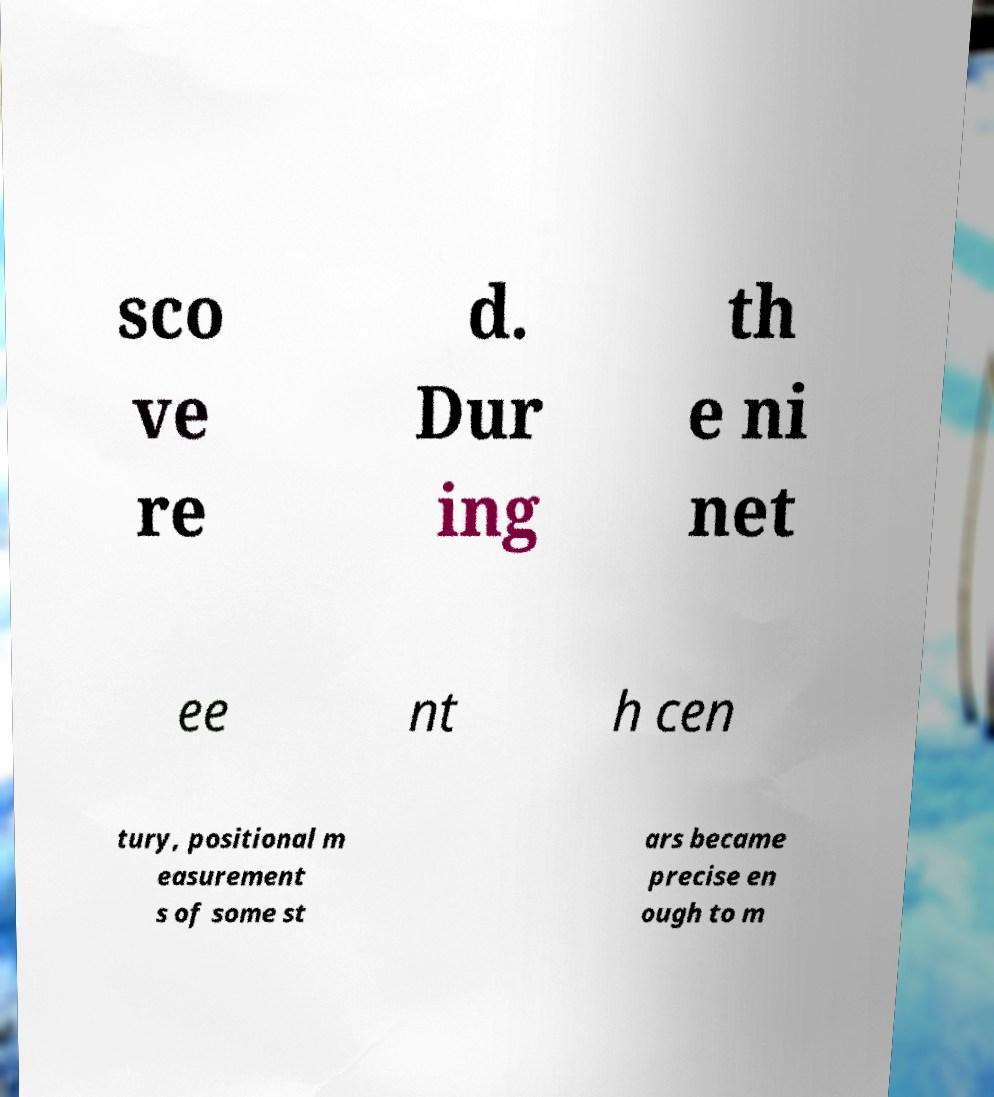Could you assist in decoding the text presented in this image and type it out clearly? sco ve re d. Dur ing th e ni net ee nt h cen tury, positional m easurement s of some st ars became precise en ough to m 